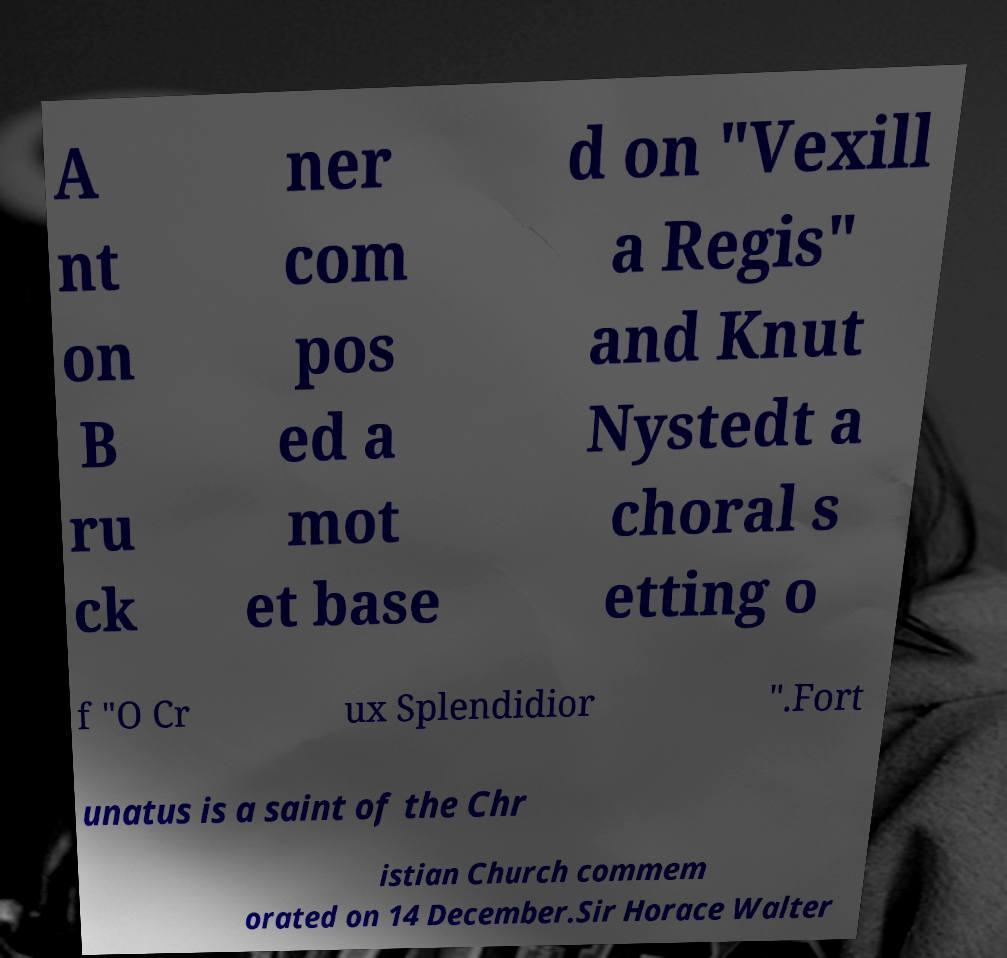For documentation purposes, I need the text within this image transcribed. Could you provide that? A nt on B ru ck ner com pos ed a mot et base d on "Vexill a Regis" and Knut Nystedt a choral s etting o f "O Cr ux Splendidior ".Fort unatus is a saint of the Chr istian Church commem orated on 14 December.Sir Horace Walter 